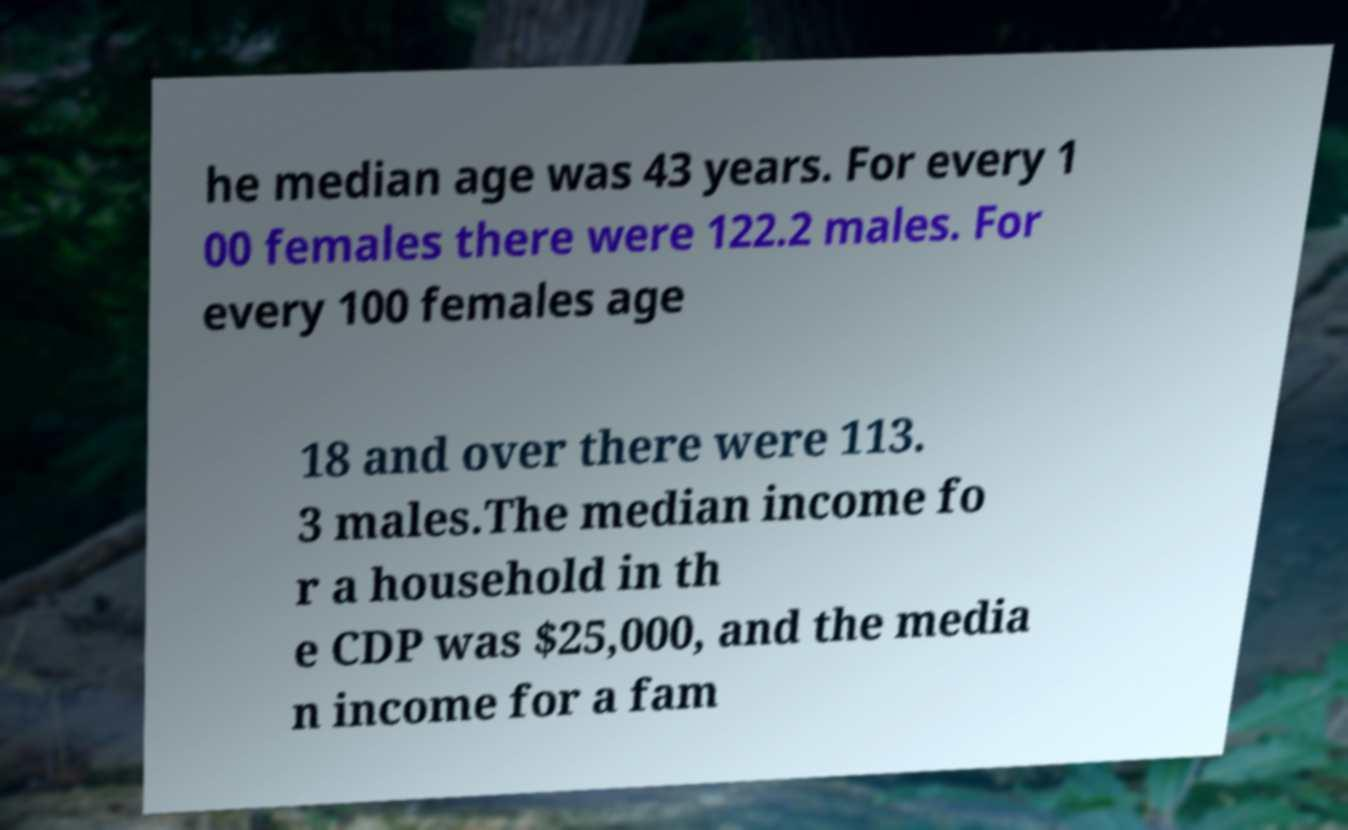For documentation purposes, I need the text within this image transcribed. Could you provide that? he median age was 43 years. For every 1 00 females there were 122.2 males. For every 100 females age 18 and over there were 113. 3 males.The median income fo r a household in th e CDP was $25,000, and the media n income for a fam 